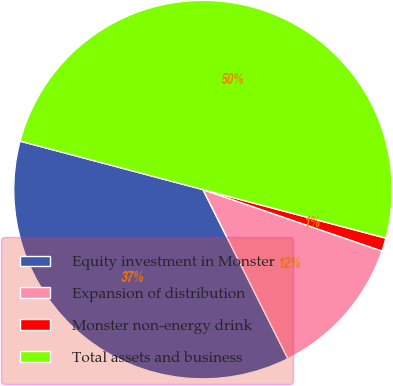<chart> <loc_0><loc_0><loc_500><loc_500><pie_chart><fcel>Equity investment in Monster<fcel>Expansion of distribution<fcel>Monster non-energy drink<fcel>Total assets and business<nl><fcel>36.53%<fcel>12.33%<fcel>1.13%<fcel>50.0%<nl></chart> 